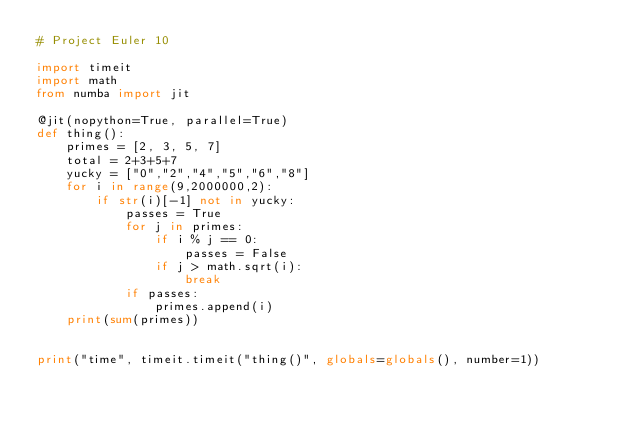<code> <loc_0><loc_0><loc_500><loc_500><_Python_># Project Euler 10

import timeit
import math
from numba import jit

@jit(nopython=True, parallel=True)
def thing():
    primes = [2, 3, 5, 7]
    total = 2+3+5+7
    yucky = ["0","2","4","5","6","8"]
    for i in range(9,2000000,2):
        if str(i)[-1] not in yucky:
            passes = True
            for j in primes:
                if i % j == 0:
                    passes = False
                if j > math.sqrt(i):
                    break
            if passes:
                primes.append(i)
    print(sum(primes))

        
print("time", timeit.timeit("thing()", globals=globals(), number=1))
</code> 